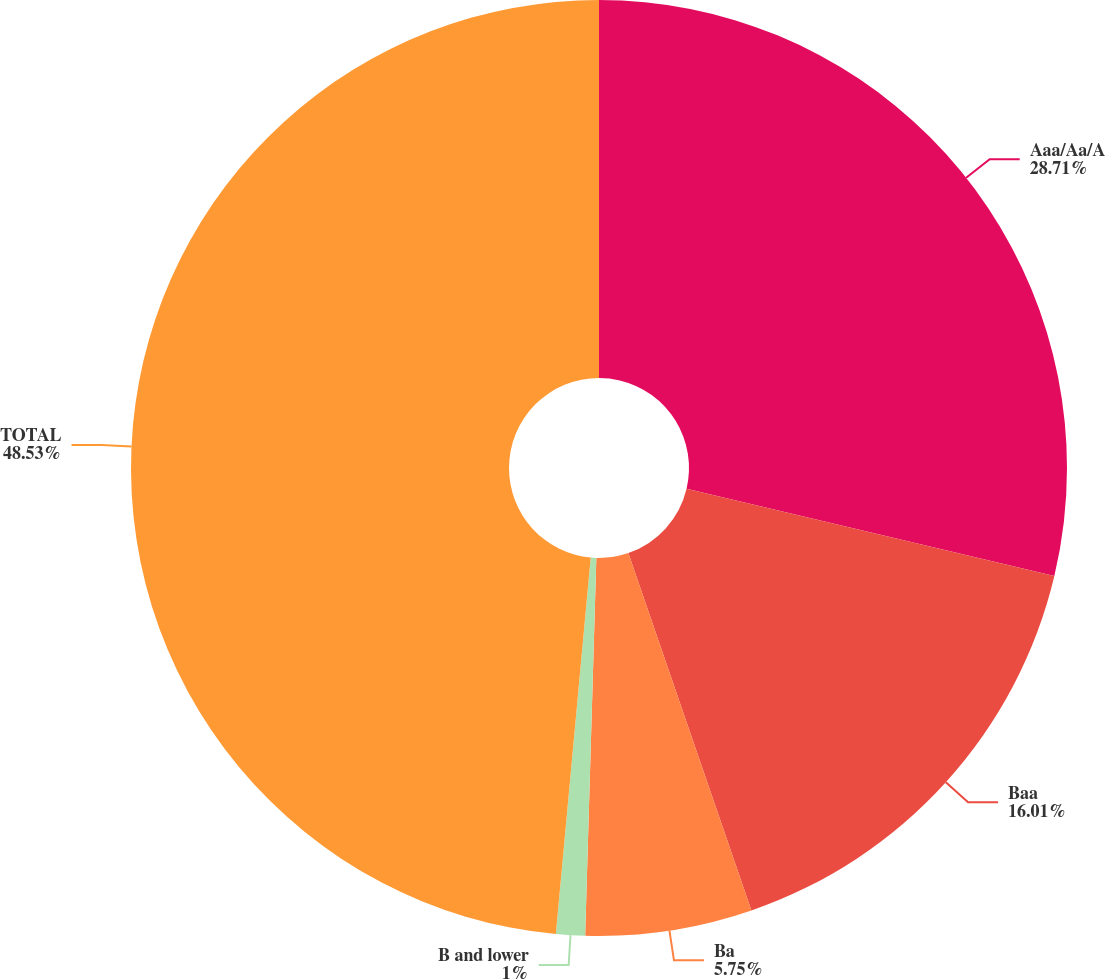<chart> <loc_0><loc_0><loc_500><loc_500><pie_chart><fcel>Aaa/Aa/A<fcel>Baa<fcel>Ba<fcel>B and lower<fcel>TOTAL<nl><fcel>28.71%<fcel>16.01%<fcel>5.75%<fcel>1.0%<fcel>48.53%<nl></chart> 